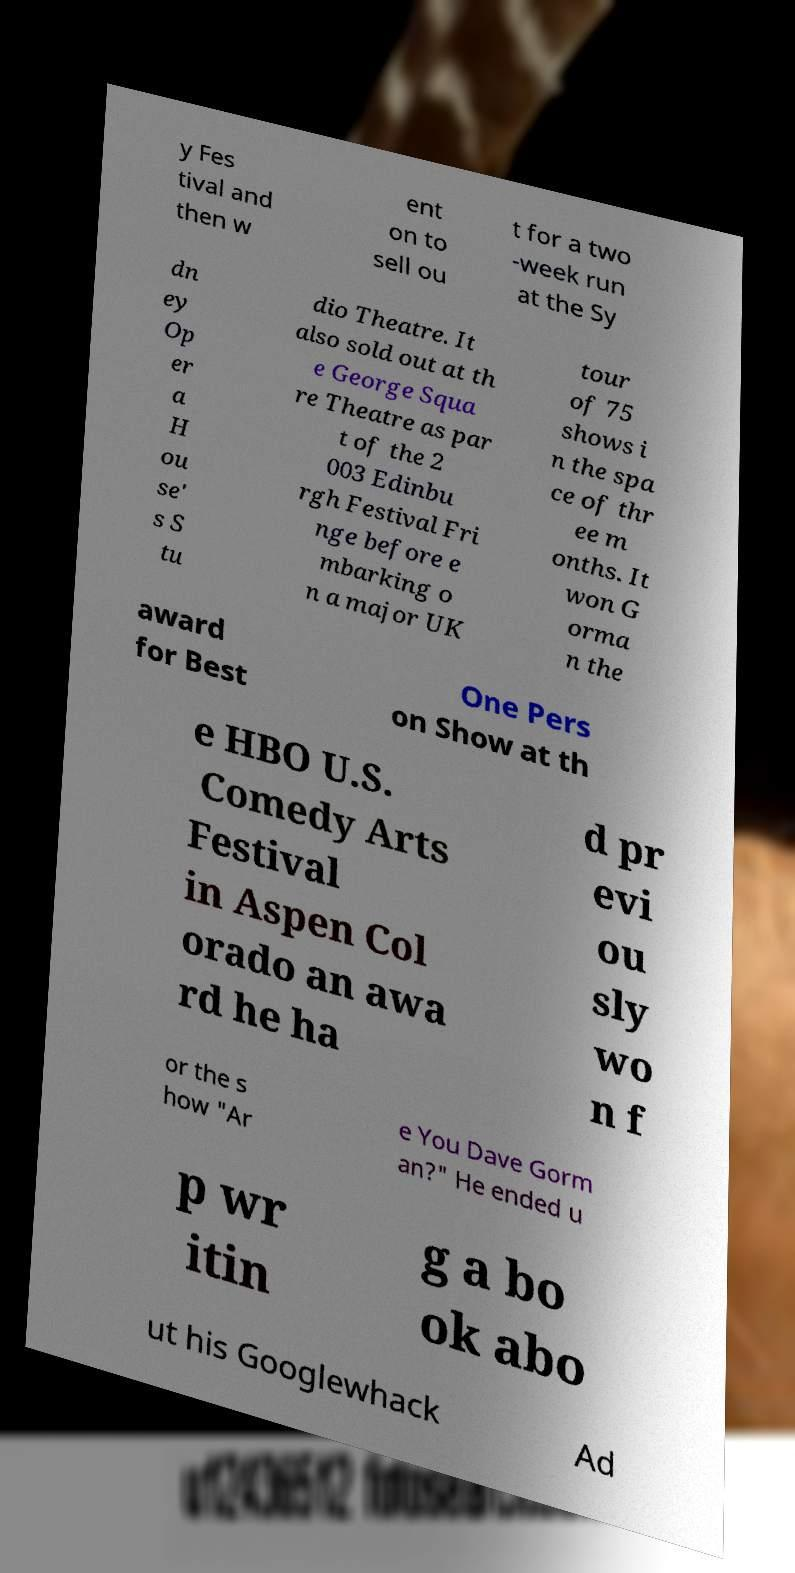I need the written content from this picture converted into text. Can you do that? y Fes tival and then w ent on to sell ou t for a two -week run at the Sy dn ey Op er a H ou se' s S tu dio Theatre. It also sold out at th e George Squa re Theatre as par t of the 2 003 Edinbu rgh Festival Fri nge before e mbarking o n a major UK tour of 75 shows i n the spa ce of thr ee m onths. It won G orma n the award for Best One Pers on Show at th e HBO U.S. Comedy Arts Festival in Aspen Col orado an awa rd he ha d pr evi ou sly wo n f or the s how "Ar e You Dave Gorm an?" He ended u p wr itin g a bo ok abo ut his Googlewhack Ad 